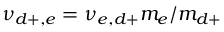<formula> <loc_0><loc_0><loc_500><loc_500>\nu _ { d + , e } = \nu _ { e , d + } m _ { e } / m _ { d + }</formula> 